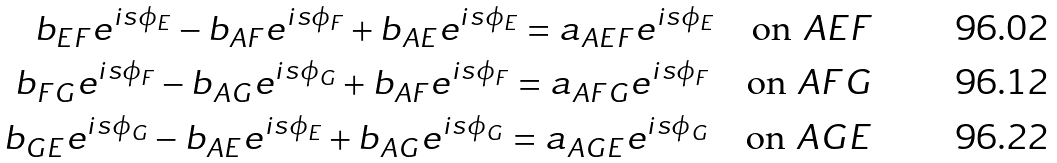<formula> <loc_0><loc_0><loc_500><loc_500>b _ { E F } e ^ { i s \phi _ { E } } - b _ { A F } e ^ { i s \phi _ { F } } + b _ { A E } e ^ { i s \phi _ { E } } = a _ { A E F } e ^ { i s \phi _ { E } } \quad \text {on } A E F \\ b _ { F G } e ^ { i s \phi _ { F } } - b _ { A G } e ^ { i s \phi _ { G } } + b _ { A F } e ^ { i s \phi _ { F } } = a _ { A F G } e ^ { i s \phi _ { F } } \quad \text {on } A F G \\ b _ { G E } e ^ { i s \phi _ { G } } - b _ { A E } e ^ { i s \phi _ { E } } + b _ { A G } e ^ { i s \phi _ { G } } = a _ { A G E } e ^ { i s \phi _ { G } } \quad \text {on } A G E</formula> 